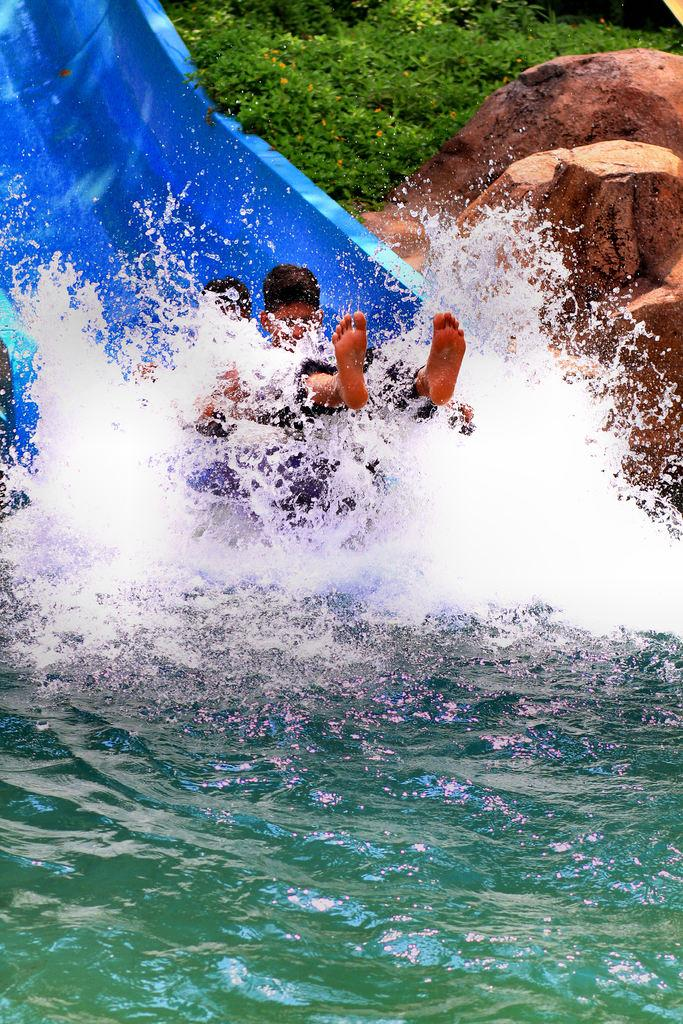What are the people in the image doing? There are people on a slide in the image. What is at the end of the slide? There is water at the bottom of the slide. What can be seen in the background of the image? There are rocks and trees in the background of the image. How many kittens are playing on the slide in the image? There are no kittens present in the image; it features people on a slide. What type of curve does the slide have in the image? The image does not provide information about the shape or curve of the slide. 